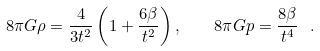<formula> <loc_0><loc_0><loc_500><loc_500>8 \pi G \rho = \frac { 4 } { 3 t ^ { 2 } } \left ( 1 + \frac { 6 \beta } { t ^ { 2 } } \right ) , \quad 8 \pi G p = \frac { 8 \beta } { t ^ { 4 } } \ .</formula> 